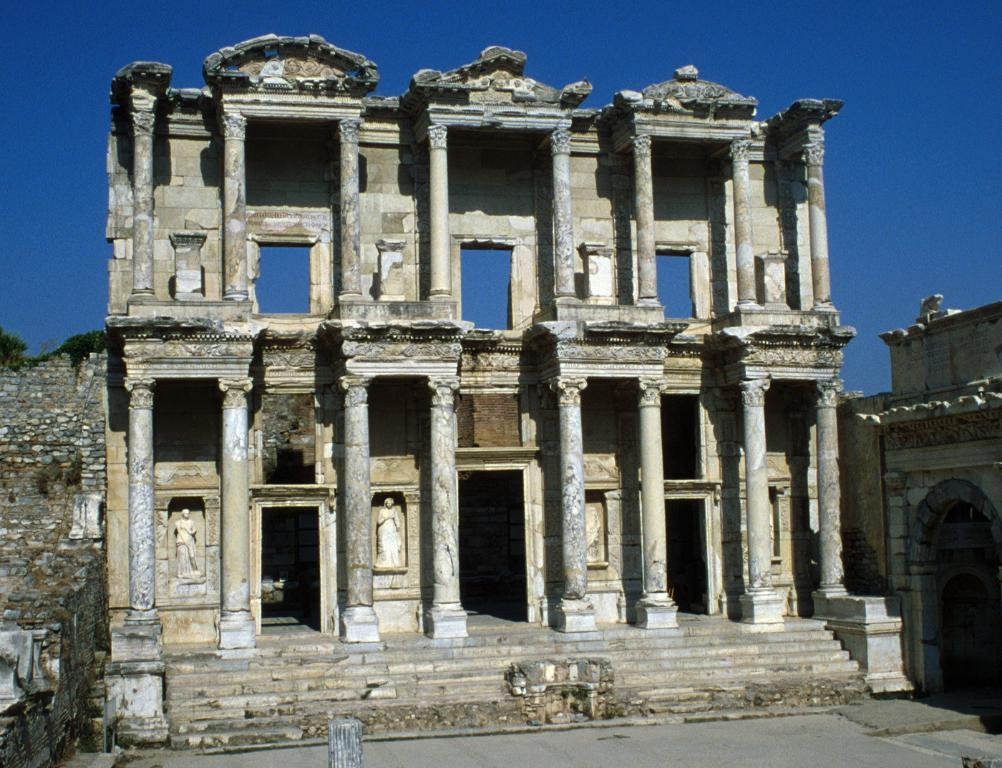What type of structure is present in the image? There is a building in the image. What architectural features can be seen on the building? The building has pillars and walls. What is visible at the top of the image? The sky is visible at the top of the image. What is the color of the sky in the image? The sky is blue in color. What is visible at the bottom of the image? There is ground visible at the bottom of the image. Can you see any clovers growing on the ground in the image? There are no clovers visible in the image; only the building, sky, and ground are present. 